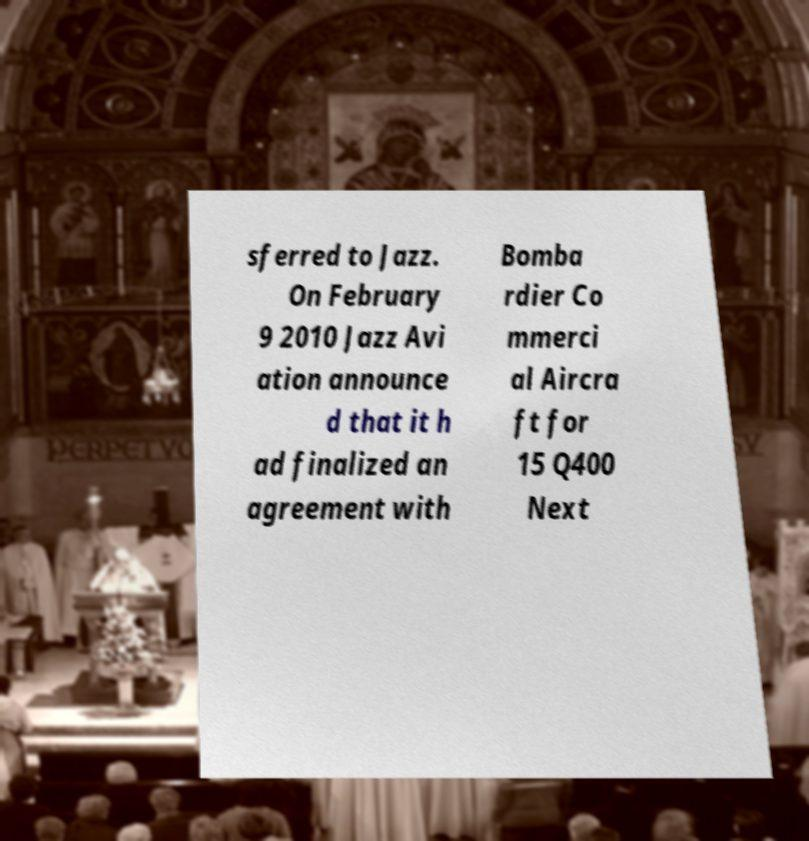Could you assist in decoding the text presented in this image and type it out clearly? sferred to Jazz. On February 9 2010 Jazz Avi ation announce d that it h ad finalized an agreement with Bomba rdier Co mmerci al Aircra ft for 15 Q400 Next 